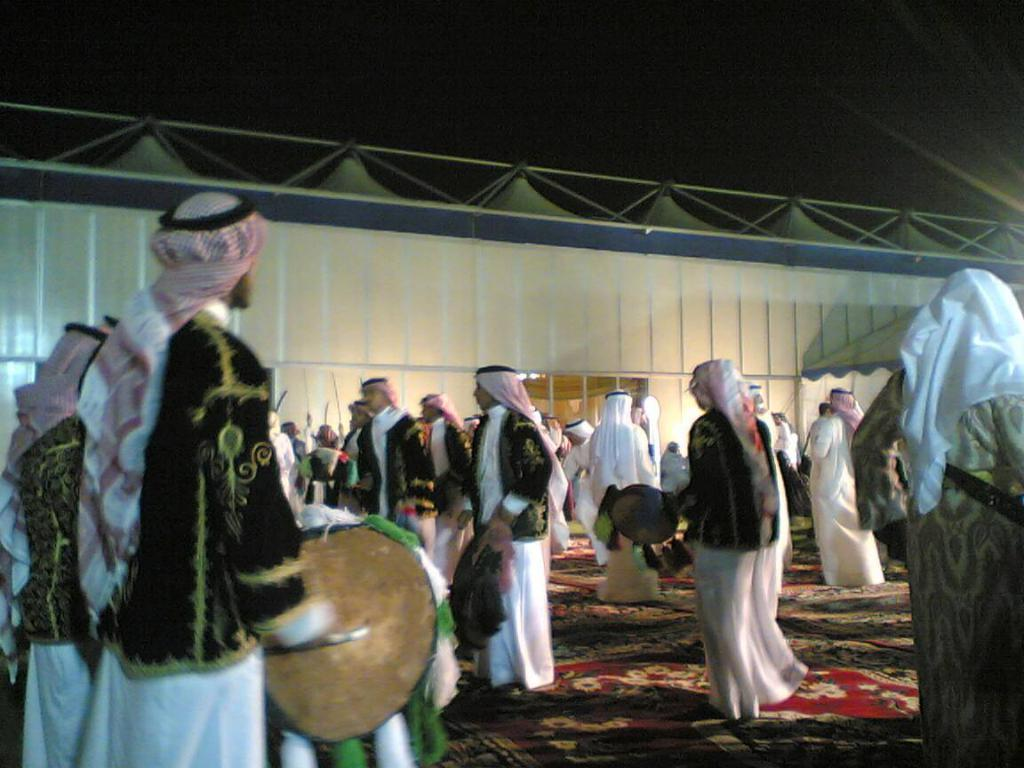What is the main subject of the image? The main subject of the image is a group of people. What are the people wearing in the image? The people are wearing white-colored dresses in the image. What are some of the people doing in the image? Some people are playing musical instruments in the image. What is the position of the people in the image? The people are standing in the image. What can be seen in the background of the image? The background of the image is white. Can you tell me how many trails are visible in the image? There are no trails visible in the image; it features a group of people wearing white-colored dresses, some of whom are playing musical instruments. What type of disease is affecting the people in the image? There is no indication of any disease affecting the people in the image; they are simply standing and playing musical instruments. 